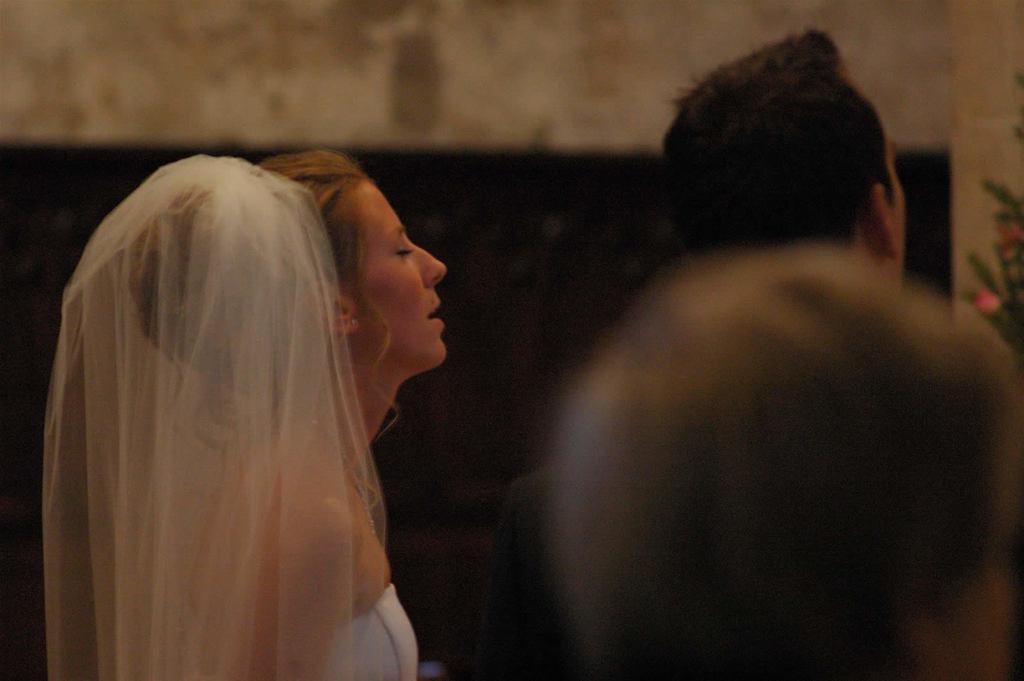Describe this image in one or two sentences. Here I can see a woman and two persons are facing towards the right side. The woman is wearing a white color dress. In the background, I can see the wall. 